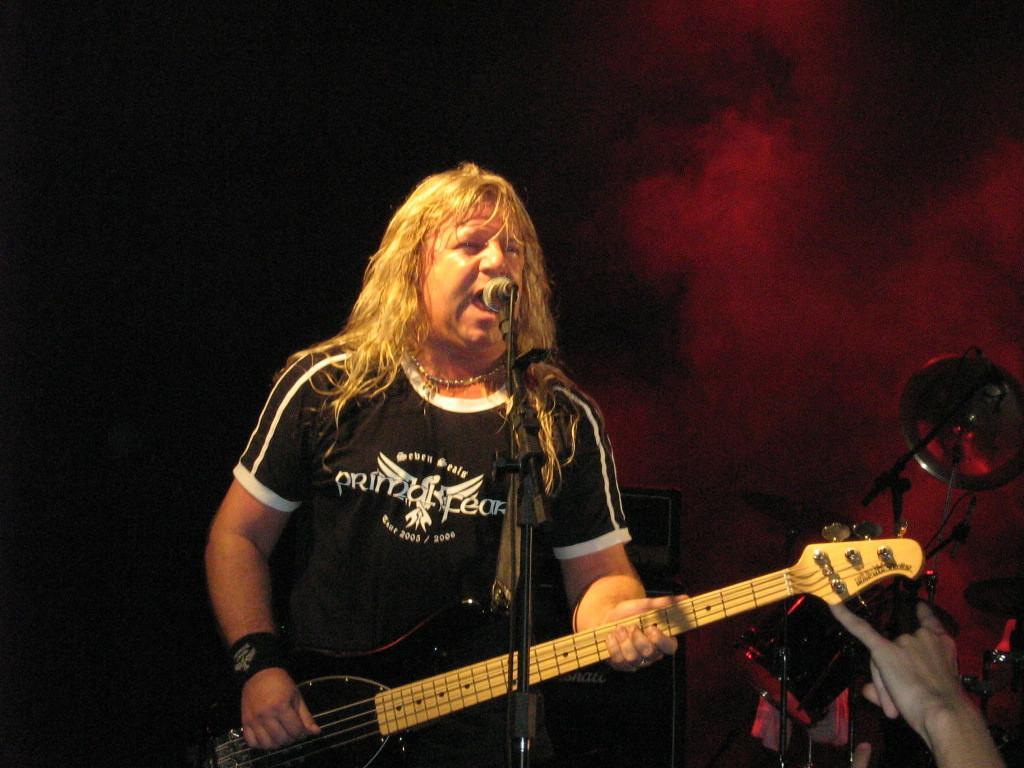How would you summarize this image in a sentence or two? In this image we can see a man standing in front of the mike and holding the guitar. We can also see some person's hand and also some other musical instruments. 